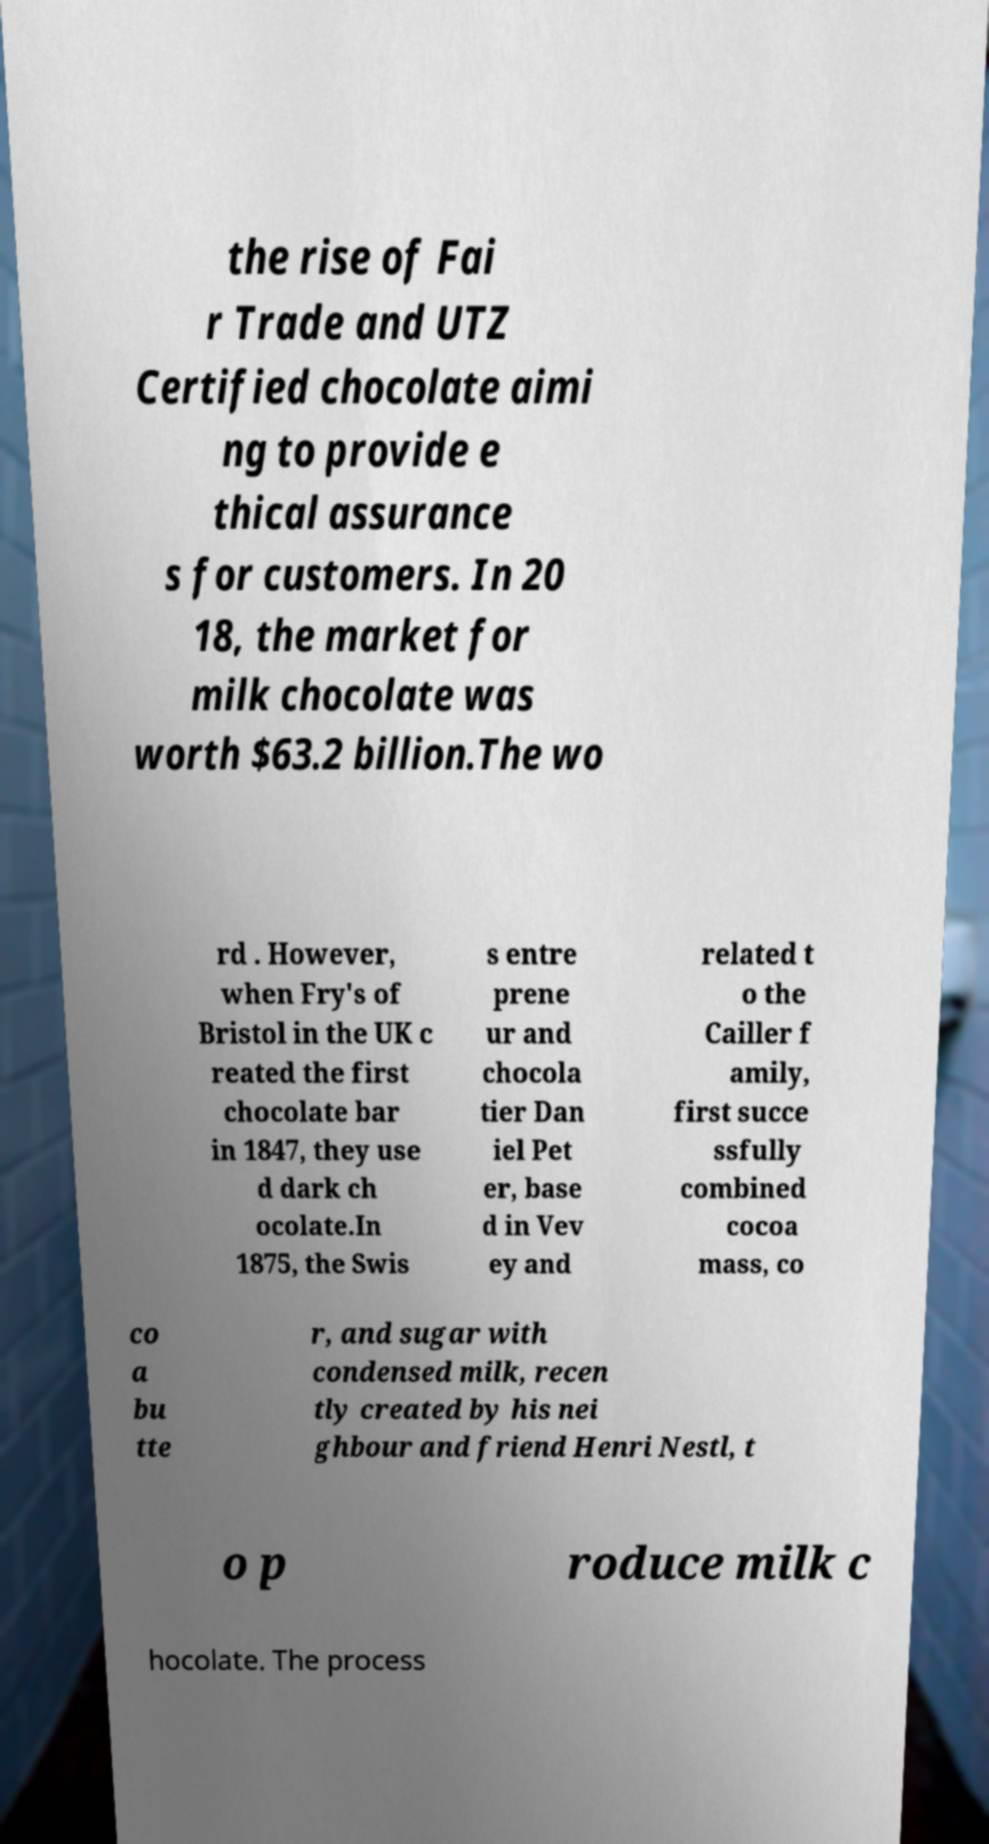For documentation purposes, I need the text within this image transcribed. Could you provide that? the rise of Fai r Trade and UTZ Certified chocolate aimi ng to provide e thical assurance s for customers. In 20 18, the market for milk chocolate was worth $63.2 billion.The wo rd . However, when Fry's of Bristol in the UK c reated the first chocolate bar in 1847, they use d dark ch ocolate.In 1875, the Swis s entre prene ur and chocola tier Dan iel Pet er, base d in Vev ey and related t o the Cailler f amily, first succe ssfully combined cocoa mass, co co a bu tte r, and sugar with condensed milk, recen tly created by his nei ghbour and friend Henri Nestl, t o p roduce milk c hocolate. The process 